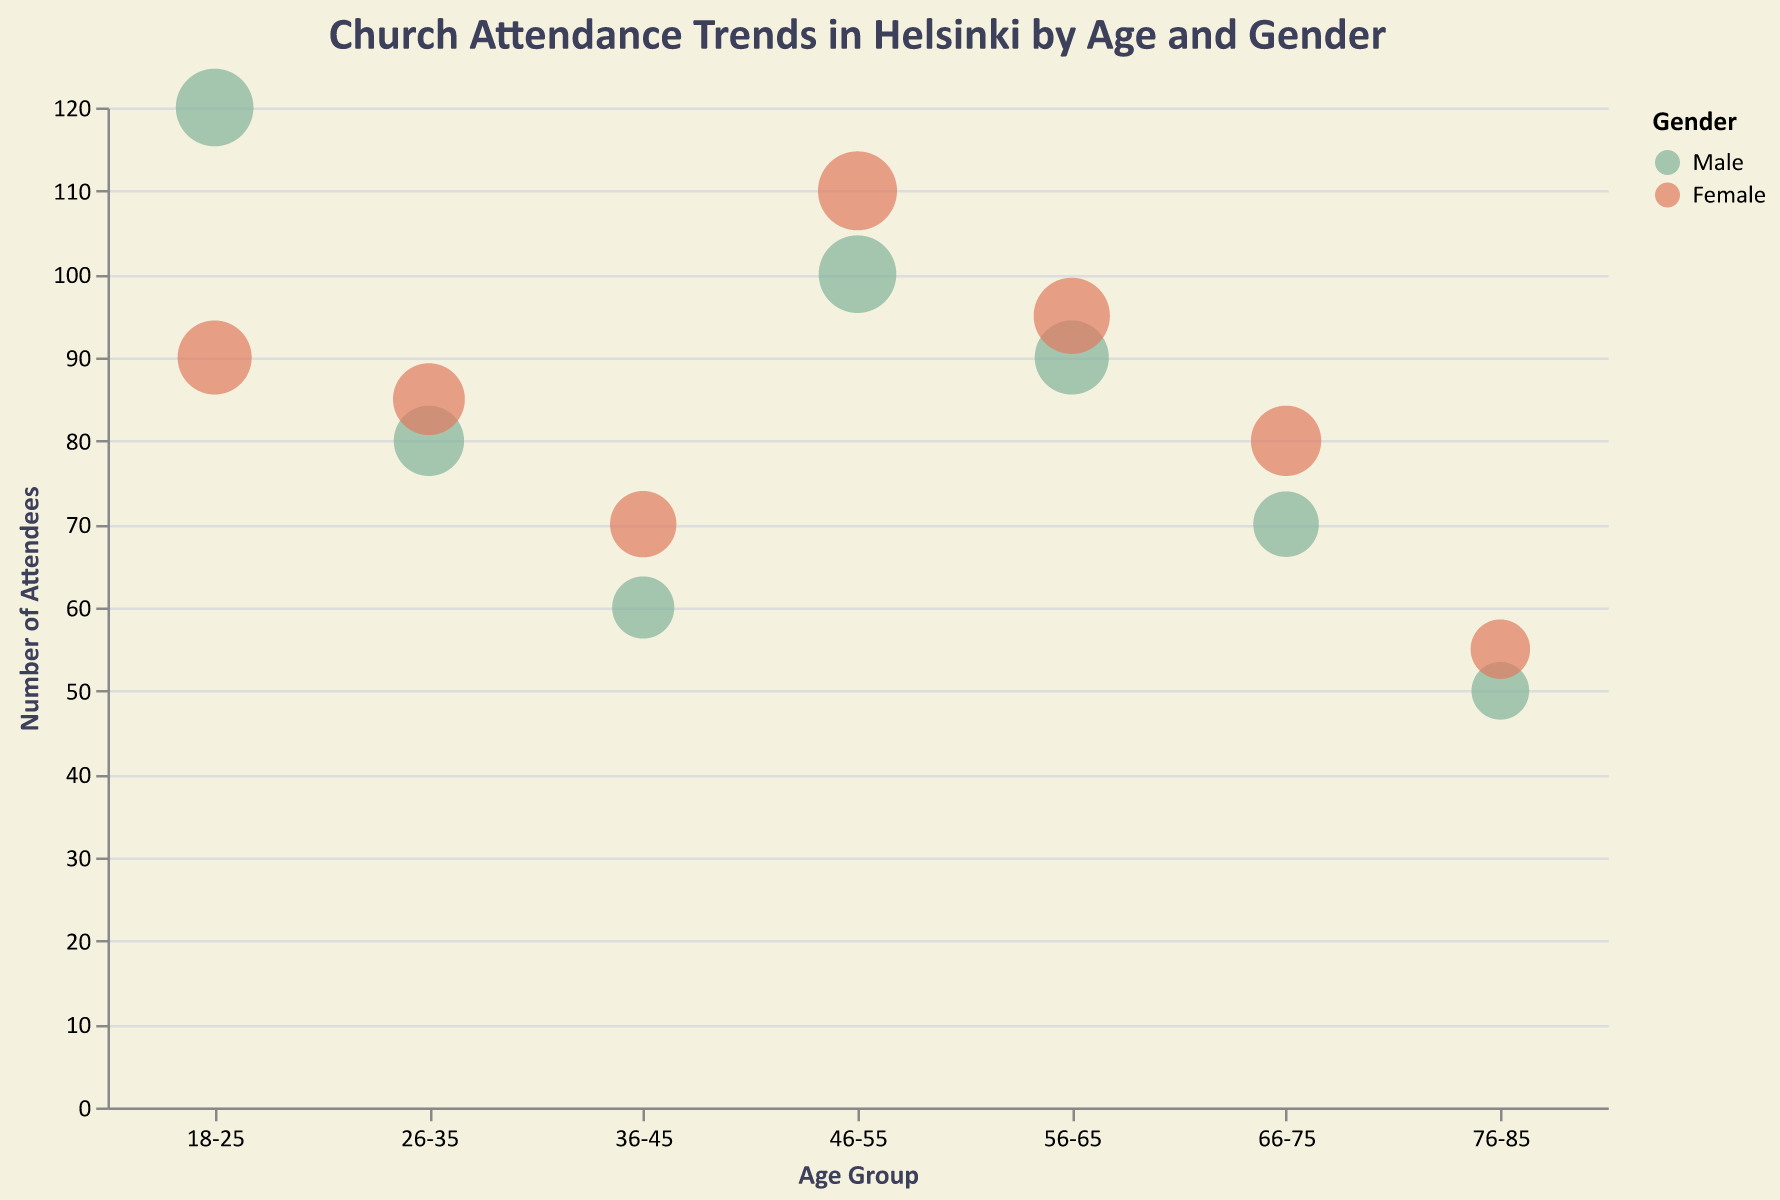What is the total number of male attendees across all churches? To find the total male attendees, sum up the numbers of male attendees: 120 (Helsinki Cathedral) + 80 (Temppeliaukio Church) + 60 (Uspenski Cathedral) + 100 (Old Church of Helsinki) + 90 (Kallio Church) + 70 (Pihlajamäki Church) + 50 (St. John's Church) = 570.
Answer: 570 Which age group has the largest bubble for female attendees? Look at the size of the bubbles for each age group for females and identify the largest one. The largest bubble size for females is in the 46-55 age group with a size of 52.
Answer: 46-55 How many more female attendees are there compared to male attendees at Helsinki Cathedral? The number of female attendees at Helsinki Cathedral is 90, and the number of male attendees is 120. The difference is 120 - 90 = 30.
Answer: 30 What is the church with the highest number of attendees in the 26-35 age group and what's the number? Look for the church with the highest attendees within the 26-35 age group. Temppeliaukio Church has 85 female attendees, which is the highest in this age group.
Answer: Temppeliaukio Church, 85 Compare the number of attendees for males and females in the 56-65 age group. Which gender has more attendees and by how much? The number of attendees for males in the 56-65 age group is 90, and for females is 95. Females have 95 - 90 = 5 more attendees than males.
Answer: Females, by 5 Which church has the smallest number of attendees for the 76-85 age group, and how many attendees are there in total at that church for this age group? The number of attendees in the 76-85 age group for males at St. John's Church is 50, and for females is 55. The total number of attendees is 50 + 55 = 105.
Answer: St. John's Church, 105 What is the average number of female attendees across all age groups for Old Church of Helsinki? The number of female attendees in the 46-55 age group at Old Church of Helsinki is 110. As there’s only one age group listed for Old Church of Helsinki, the average is 110.
Answer: 110 Which gender has a greater attendance in the age group 66-75, and by what percentage is it higher? The number of male attendees in the 66-75 age group is 70, and the number of female attendees is 80. The difference is 80 - 70 = 10. To find the percentage, (10/70) * 100 = ~14.29%.
Answer: Female, ~14.29% Summarize the attendance trend as age increases. From the figure, we can see that the attendance decreases with increasing age. The highest attendance is among younger age groups like 18-25, which then gradually declines to the 76-85 age group.
Answer: Decreases with age How does the attendance at Kallio Church compare between males and females? The number of male attendees at Kallio Church is 90, and the number of female attendees is 95. Females have slightly higher attendance.
Answer: Females have higher attendance 